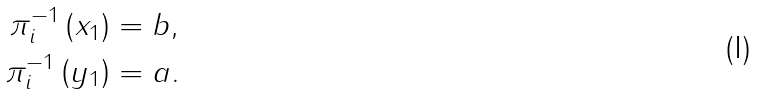<formula> <loc_0><loc_0><loc_500><loc_500>\pi _ { i } ^ { - 1 } \left ( x _ { 1 } \right ) & = b , \\ \pi _ { i } ^ { - 1 } \left ( y _ { 1 } \right ) & = a .</formula> 